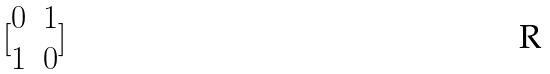Convert formula to latex. <formula><loc_0><loc_0><loc_500><loc_500>[ \begin{matrix} 0 & 1 \\ 1 & 0 \end{matrix} ]</formula> 